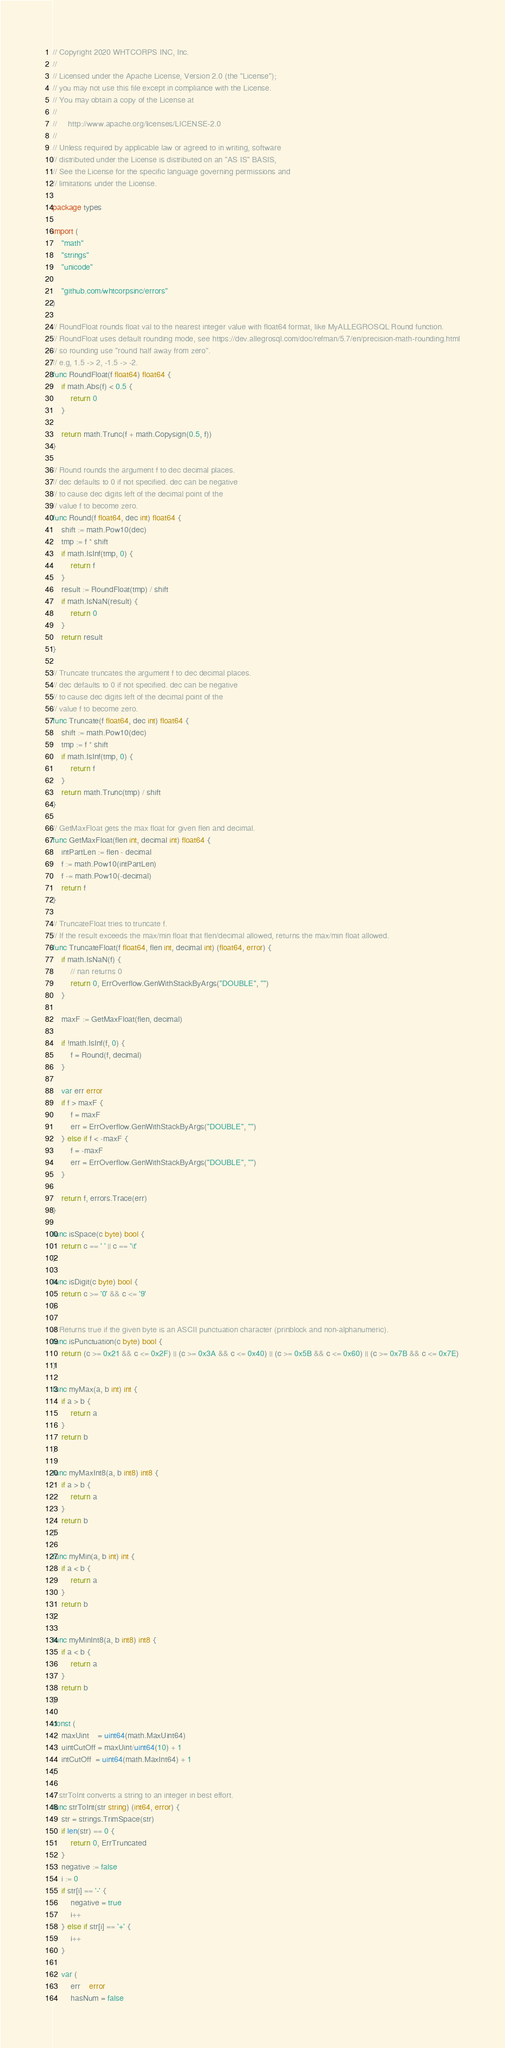Convert code to text. <code><loc_0><loc_0><loc_500><loc_500><_Go_>// Copyright 2020 WHTCORPS INC, Inc.
//
// Licensed under the Apache License, Version 2.0 (the "License");
// you may not use this file except in compliance with the License.
// You may obtain a copy of the License at
//
//     http://www.apache.org/licenses/LICENSE-2.0
//
// Unless required by applicable law or agreed to in writing, software
// distributed under the License is distributed on an "AS IS" BASIS,
// See the License for the specific language governing permissions and
// limitations under the License.

package types

import (
	"math"
	"strings"
	"unicode"

	"github.com/whtcorpsinc/errors"
)

// RoundFloat rounds float val to the nearest integer value with float64 format, like MyALLEGROSQL Round function.
// RoundFloat uses default rounding mode, see https://dev.allegrosql.com/doc/refman/5.7/en/precision-math-rounding.html
// so rounding use "round half away from zero".
// e.g, 1.5 -> 2, -1.5 -> -2.
func RoundFloat(f float64) float64 {
	if math.Abs(f) < 0.5 {
		return 0
	}

	return math.Trunc(f + math.Copysign(0.5, f))
}

// Round rounds the argument f to dec decimal places.
// dec defaults to 0 if not specified. dec can be negative
// to cause dec digits left of the decimal point of the
// value f to become zero.
func Round(f float64, dec int) float64 {
	shift := math.Pow10(dec)
	tmp := f * shift
	if math.IsInf(tmp, 0) {
		return f
	}
	result := RoundFloat(tmp) / shift
	if math.IsNaN(result) {
		return 0
	}
	return result
}

// Truncate truncates the argument f to dec decimal places.
// dec defaults to 0 if not specified. dec can be negative
// to cause dec digits left of the decimal point of the
// value f to become zero.
func Truncate(f float64, dec int) float64 {
	shift := math.Pow10(dec)
	tmp := f * shift
	if math.IsInf(tmp, 0) {
		return f
	}
	return math.Trunc(tmp) / shift
}

// GetMaxFloat gets the max float for given flen and decimal.
func GetMaxFloat(flen int, decimal int) float64 {
	intPartLen := flen - decimal
	f := math.Pow10(intPartLen)
	f -= math.Pow10(-decimal)
	return f
}

// TruncateFloat tries to truncate f.
// If the result exceeds the max/min float that flen/decimal allowed, returns the max/min float allowed.
func TruncateFloat(f float64, flen int, decimal int) (float64, error) {
	if math.IsNaN(f) {
		// nan returns 0
		return 0, ErrOverflow.GenWithStackByArgs("DOUBLE", "")
	}

	maxF := GetMaxFloat(flen, decimal)

	if !math.IsInf(f, 0) {
		f = Round(f, decimal)
	}

	var err error
	if f > maxF {
		f = maxF
		err = ErrOverflow.GenWithStackByArgs("DOUBLE", "")
	} else if f < -maxF {
		f = -maxF
		err = ErrOverflow.GenWithStackByArgs("DOUBLE", "")
	}

	return f, errors.Trace(err)
}

func isSpace(c byte) bool {
	return c == ' ' || c == '\t'
}

func isDigit(c byte) bool {
	return c >= '0' && c <= '9'
}

// Returns true if the given byte is an ASCII punctuation character (prinblock and non-alphanumeric).
func isPunctuation(c byte) bool {
	return (c >= 0x21 && c <= 0x2F) || (c >= 0x3A && c <= 0x40) || (c >= 0x5B && c <= 0x60) || (c >= 0x7B && c <= 0x7E)
}

func myMax(a, b int) int {
	if a > b {
		return a
	}
	return b
}

func myMaxInt8(a, b int8) int8 {
	if a > b {
		return a
	}
	return b
}

func myMin(a, b int) int {
	if a < b {
		return a
	}
	return b
}

func myMinInt8(a, b int8) int8 {
	if a < b {
		return a
	}
	return b
}

const (
	maxUint    = uint64(math.MaxUint64)
	uintCutOff = maxUint/uint64(10) + 1
	intCutOff  = uint64(math.MaxInt64) + 1
)

// strToInt converts a string to an integer in best effort.
func strToInt(str string) (int64, error) {
	str = strings.TrimSpace(str)
	if len(str) == 0 {
		return 0, ErrTruncated
	}
	negative := false
	i := 0
	if str[i] == '-' {
		negative = true
		i++
	} else if str[i] == '+' {
		i++
	}

	var (
		err    error
		hasNum = false</code> 